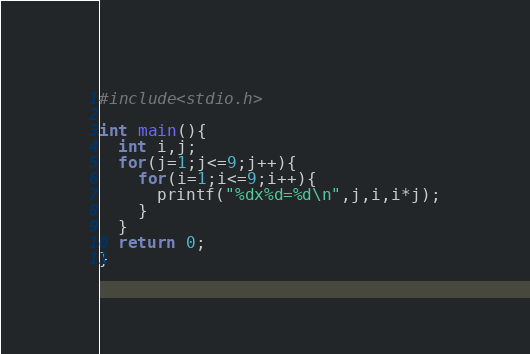<code> <loc_0><loc_0><loc_500><loc_500><_C_>#include<stdio.h>

int main(){
  int i,j;
  for(j=1;j<=9;j++){
    for(i=1;i<=9;i++){
      printf("%dx%d=%d\n",j,i,i*j);
    }
  }
  return 0;
}</code> 